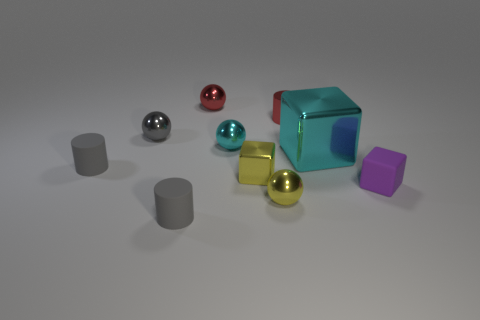How many cubes are visible in the image? In the image, there is one prominent cyan cube visible. 